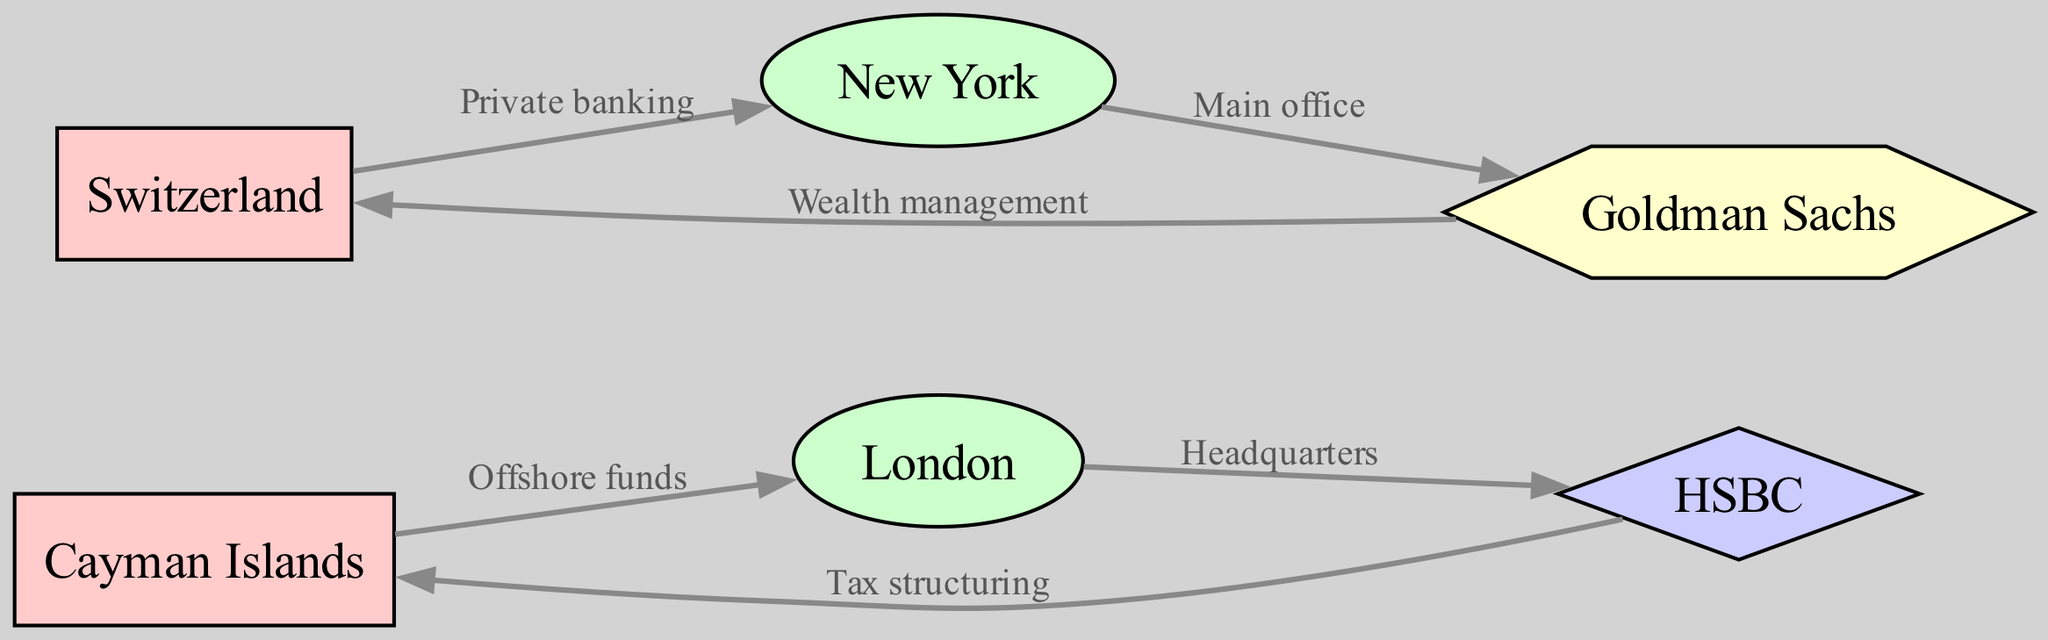What are the types of nodes represented in the diagram? The diagram includes three types of nodes: Tax Haven, Financial Center, and Global Bank. These categories help classify the roles of the entities involved in international taxation.
Answer: Tax Haven, Financial Center, Global Bank How many nodes are in the diagram? By counting the individual entities listed, we find there are 6 nodes in total: 2 tax havens, 2 financial centers, 1 global bank, and 1 investment bank.
Answer: 6 What connection exists between the Cayman Islands and London? The diagram shows a direct edge labeled "Offshore funds" between the Cayman Islands and London, indicating a specific financial relationship.
Answer: Offshore funds Which global bank is connected to the Cayman Islands? The connection from HSBC to the Cayman Islands is labeled "Tax structuring," signifying that this global bank has a financial involvement with the tax haven.
Answer: HSBC What type of relationship exists between Switzerland and New York? No direct edge is depicted between Switzerland and New York in the diagram; therefore, no relationship is specified.
Answer: None Which financial center has a connection to Goldman Sachs? The diagram indicates that Goldman Sachs is connected to New York with the label "Main office," showing that this financial center serves as the primary location for the investment bank.
Answer: New York How many edges are in the diagram? The number of edges can be determined by counting the connections between nodes, which leads us to find a total of 6 edges.
Answer: 6 What type of edge connects Goldman Sachs and Switzerland? There is an edge labeled "Wealth management" from Goldman Sachs to Switzerland, indicating a specific service relationship from the investment bank to the tax haven.
Answer: Wealth management Which node is connected to both tax havens? HSBC connects to the Cayman Islands, and Goldman Sachs connects to Switzerland, establishing connections from both global financial institutions to each tax haven.
Answer: HSBC, Goldman Sachs 